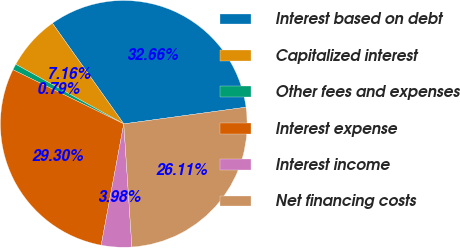<chart> <loc_0><loc_0><loc_500><loc_500><pie_chart><fcel>Interest based on debt<fcel>Capitalized interest<fcel>Other fees and expenses<fcel>Interest expense<fcel>Interest income<fcel>Net financing costs<nl><fcel>32.66%<fcel>7.16%<fcel>0.79%<fcel>29.3%<fcel>3.98%<fcel>26.11%<nl></chart> 